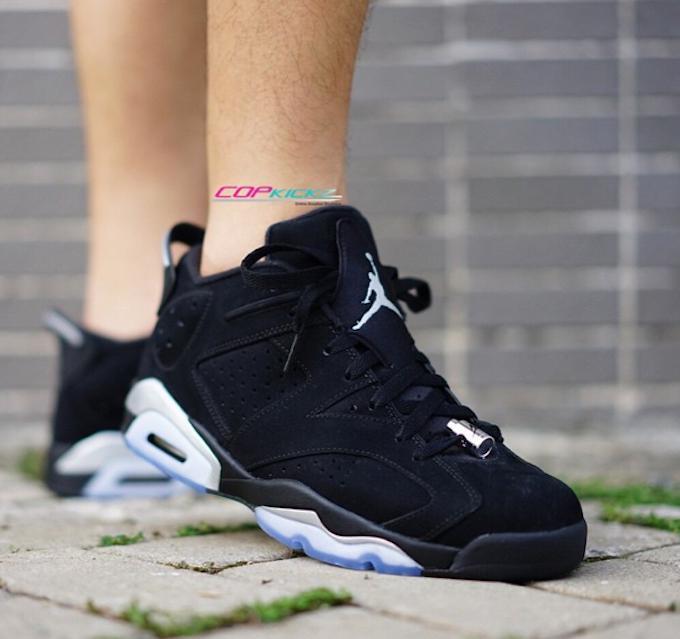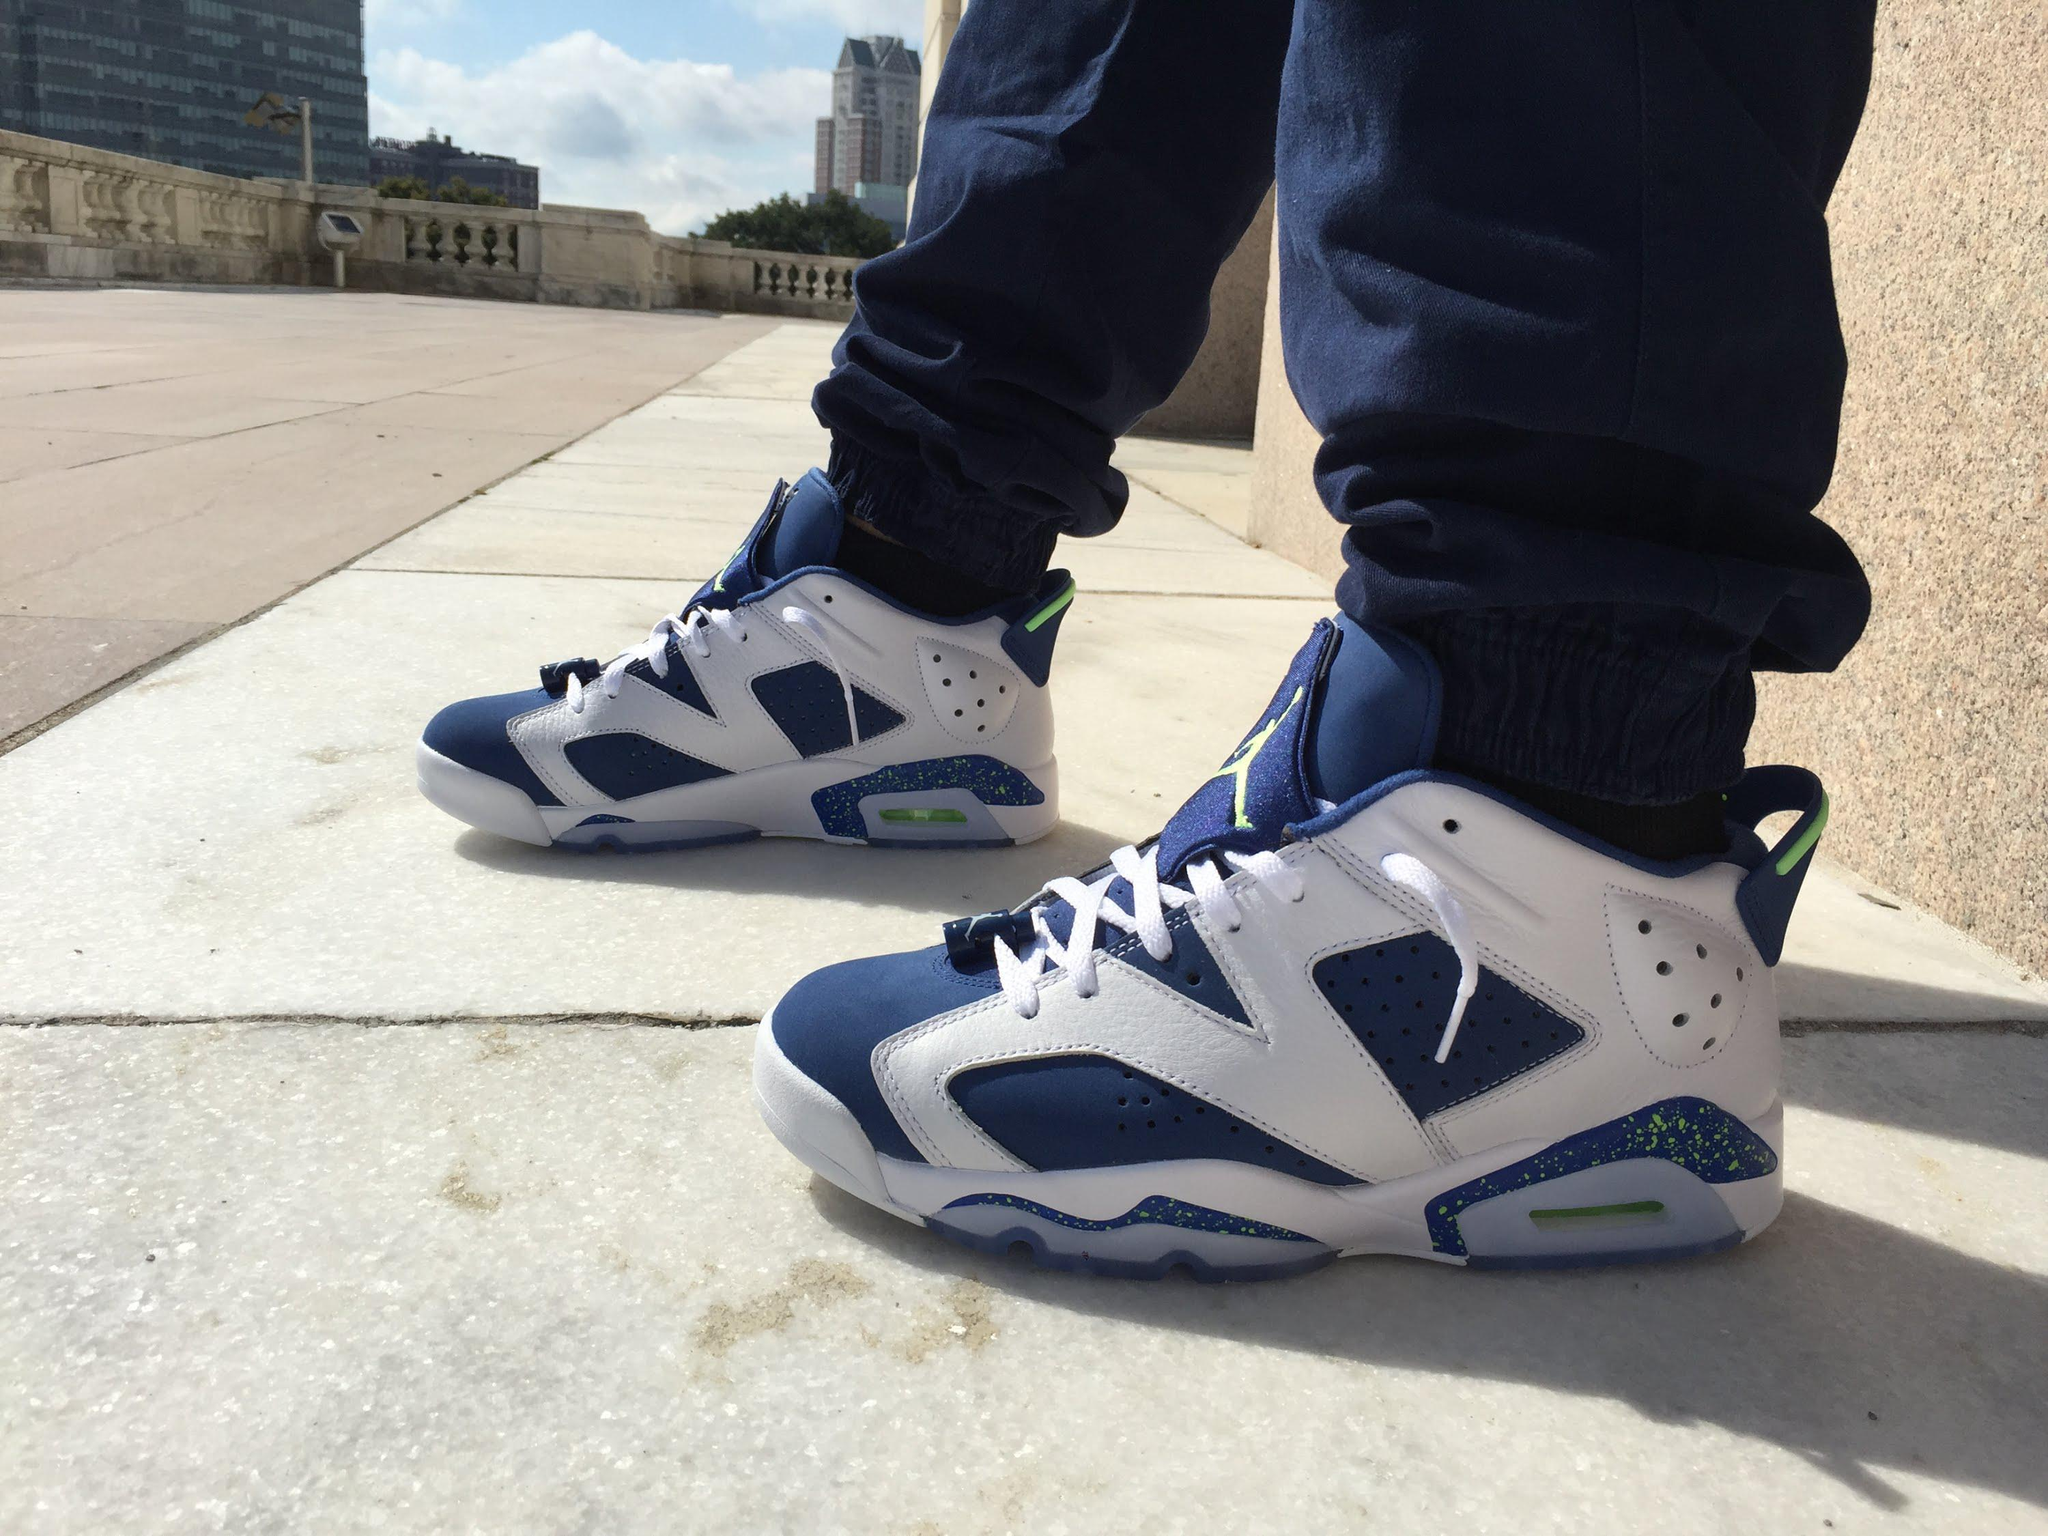The first image is the image on the left, the second image is the image on the right. For the images displayed, is the sentence "At least one pair of shoes does not have any red color in it." factually correct? Answer yes or no. Yes. The first image is the image on the left, the second image is the image on the right. Analyze the images presented: Is the assertion "At least one pair of sneakers is not shown worn by a person, and at least one pair of sneakers has red-and-white coloring." valid? Answer yes or no. No. 